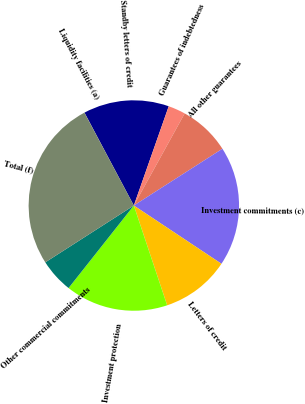Convert chart. <chart><loc_0><loc_0><loc_500><loc_500><pie_chart><fcel>Liquidity facilities (a)<fcel>Standby letters of credit<fcel>Guarantees of indebtedness<fcel>All other guarantees<fcel>Investment commitments (c)<fcel>Letters of credit<fcel>Investment protection<fcel>Other commercial commitments<fcel>Total (f)<nl><fcel>0.02%<fcel>13.15%<fcel>2.65%<fcel>7.9%<fcel>18.41%<fcel>10.53%<fcel>15.78%<fcel>5.27%<fcel>26.29%<nl></chart> 